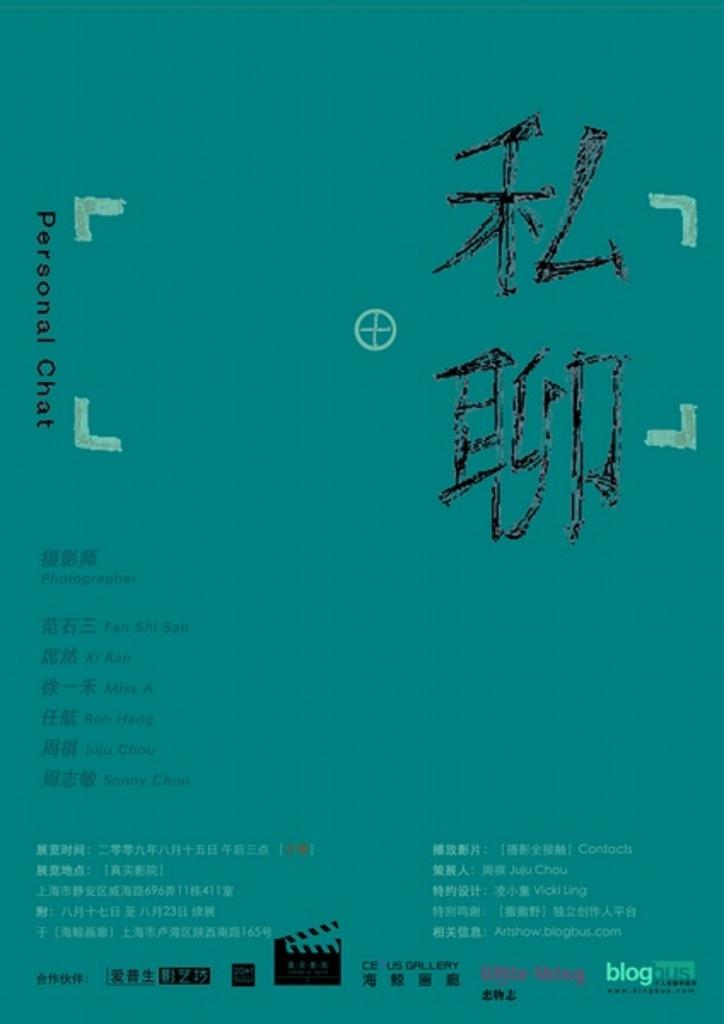Provide a one-sentence caption for the provided image. An aqua colored paper with Asian text as well as the the words "personal chat" written on it. 